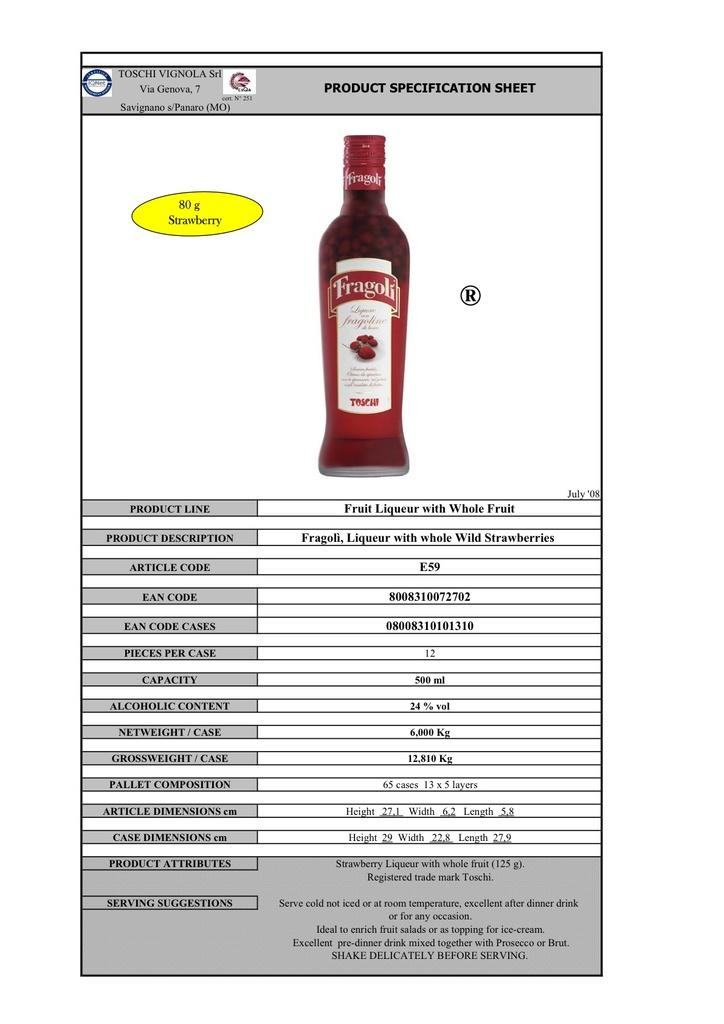<image>
Create a compact narrative representing the image presented. Product Specification sheet for  Fragoli Liqueur with whole fruit. 